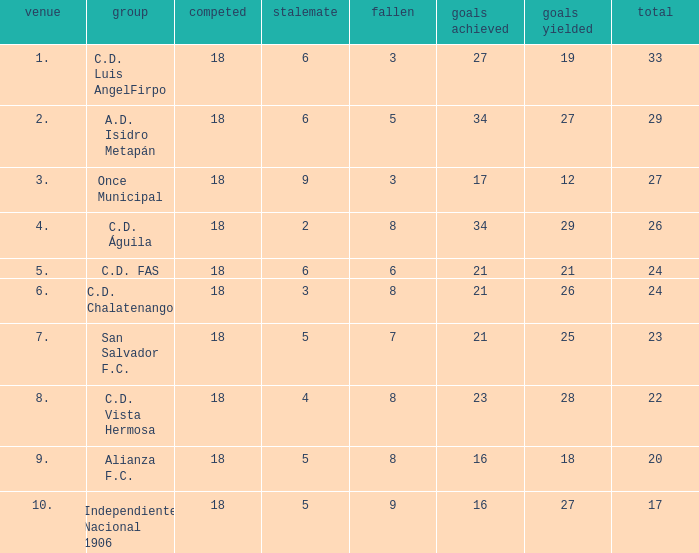For Once Municipal, what were the goals scored that had less than 27 points and greater than place 1? None. 